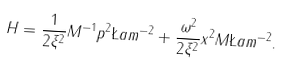<formula> <loc_0><loc_0><loc_500><loc_500>H = \frac { 1 } { 2 \xi ^ { 2 } } M ^ { - 1 } p ^ { 2 } \L a m ^ { - 2 } + \frac { \omega ^ { 2 } } { 2 \xi ^ { 2 } } x ^ { 2 } M \L a m ^ { - 2 } .</formula> 